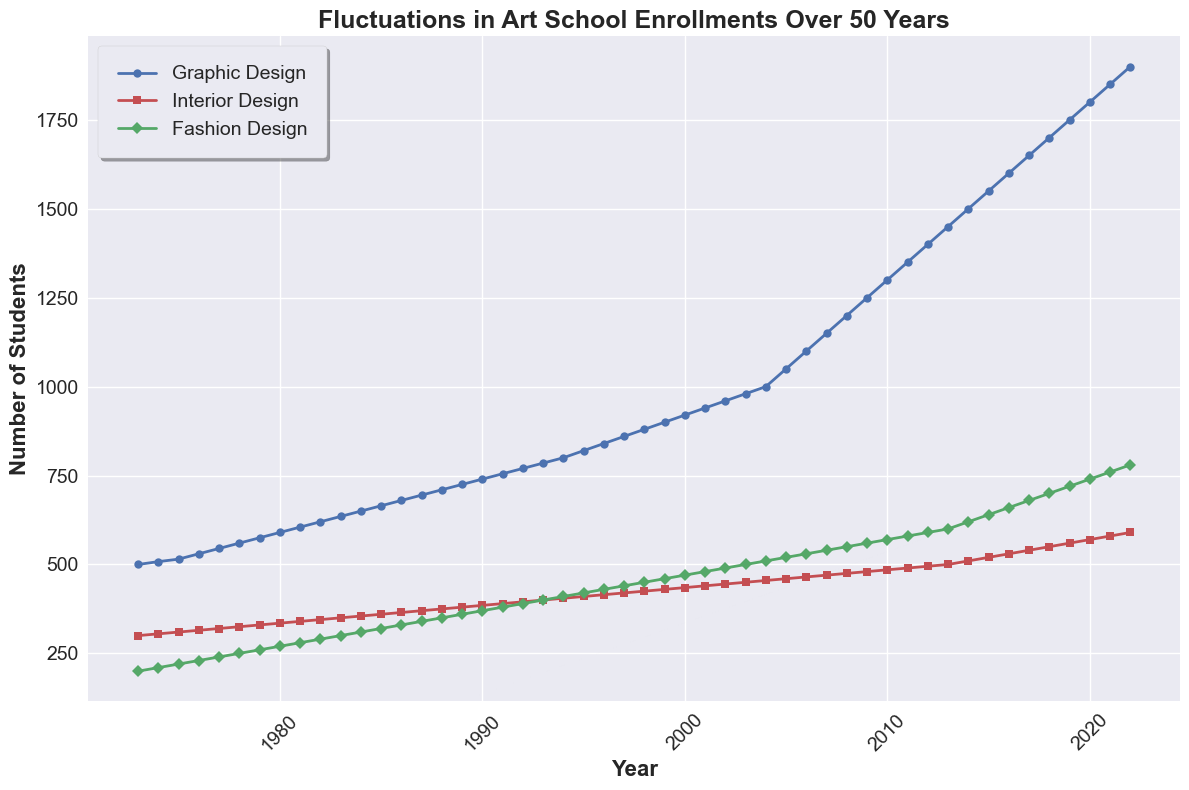What is the overall trend for enrollments in Graphic Design over the 50 years? By observing the blue line representing Graphic Design, we see it starts from 500 in 1973 and continually increases, reaching 1900 in 2022. This shows a consistent upward trend.
Answer: Upward trend In which year did Fashion Design enrollment surpass 500 students? The green line represents Fashion Design. By tracing this line, it crosses the 500-student mark between 2012 and 2013, suggesting 2013 is the first year it surpasses 500 students.
Answer: 2013 Compare the enrollments of Interior Design and Fashion Design in the year 2000. Which has more students, and by how much? In the year 2000, Interior Design has 435 students (red line), and Fashion Design has 470 students (green line). The difference is 470 - 435 = 35.
Answer: Fashion Design by 35 What is the average enrollment of Graphic Design over the first 10 years? The number of students in Graphic Design from 1973 to 1982 is (500 + 508 + 515 + 530 + 545 + 560 + 575 + 590 + 605 + 620). The total is 5548, and the average is 5548 / 10 = 554.8.
Answer: 554.8 Between which years did the enrollment for Interior Design grow the fastest? By analyzing the red line for Interior Design, the segment with the steepest rise appears between the years 2004 (455 students) and 2005 (460 students). The growth is 460 - 455 = 5 students over one year.
Answer: 2004-2005 What's the difference in student enrollment between Graphic Design and Interior Design in 2022? In 2022, enrollments for Graphic Design are 1900 (blue line), and for Interior Design, it is 590 (red line). The difference is 1900 - 590 = 1310.
Answer: 1310 Around which year did Fashion Design enrollment reach half the enrollment of Graphic Design? Looking at where the green line (Fashion Design) approximately matches half of the blue line's values (Graphic Design), around 2016, Fashion Design reaches 660, and Graphic Design is near 1600, with half being 800.
Answer: 2016 How did the enrollment in Interior Design change from 1990 to 2000? In 1990, there were 385 students in Interior Design (red line), and in 2000, there were 435 students. The growth is 435 - 385 = 50 over 10 years.
Answer: Increase by 50 